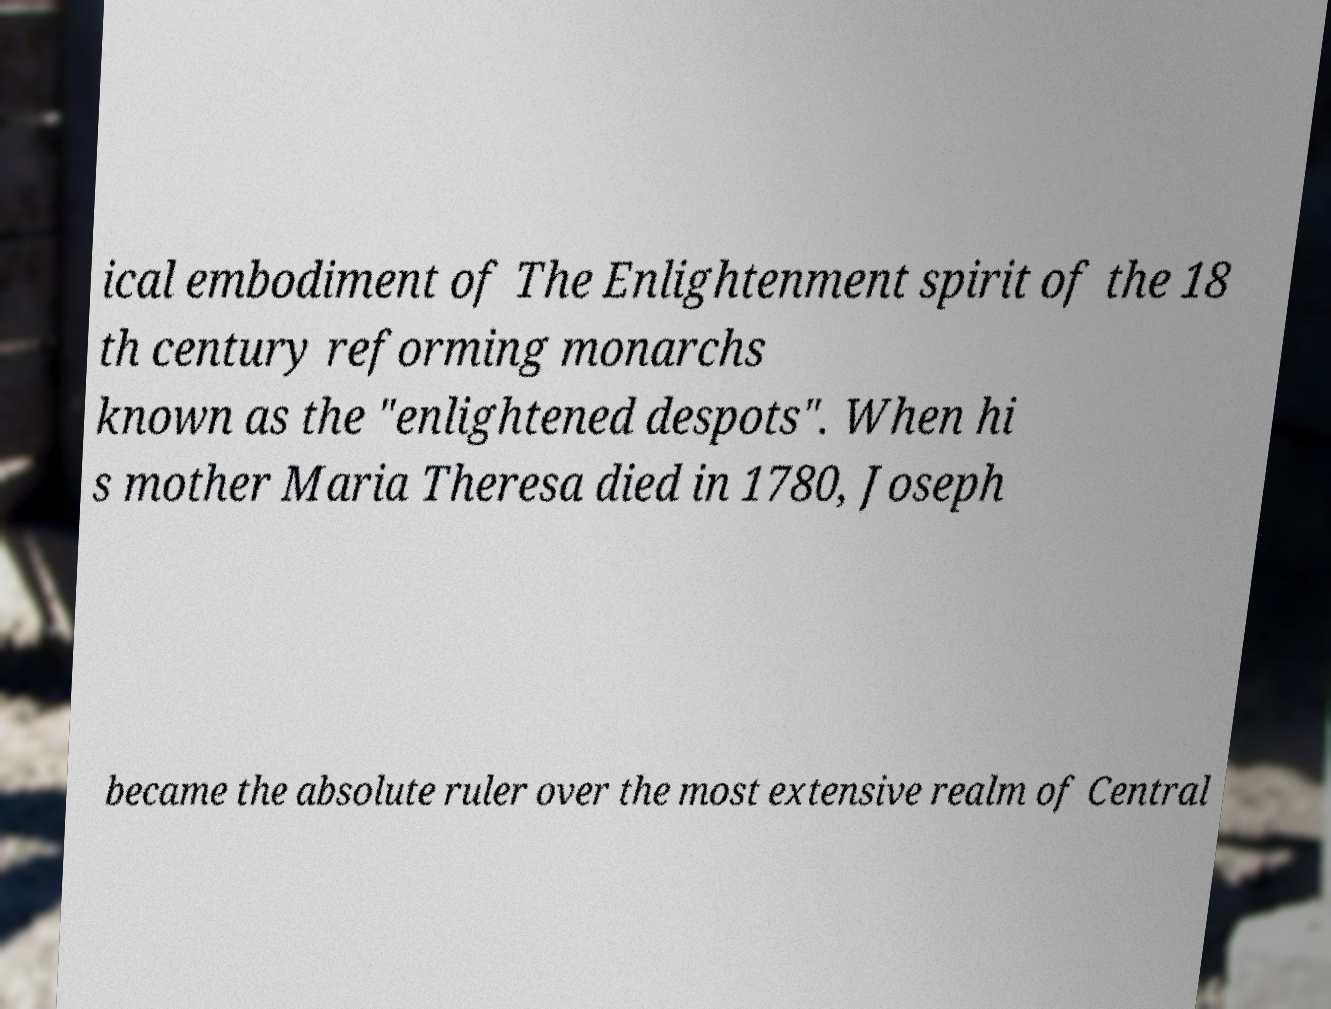For documentation purposes, I need the text within this image transcribed. Could you provide that? ical embodiment of The Enlightenment spirit of the 18 th century reforming monarchs known as the "enlightened despots". When hi s mother Maria Theresa died in 1780, Joseph became the absolute ruler over the most extensive realm of Central 